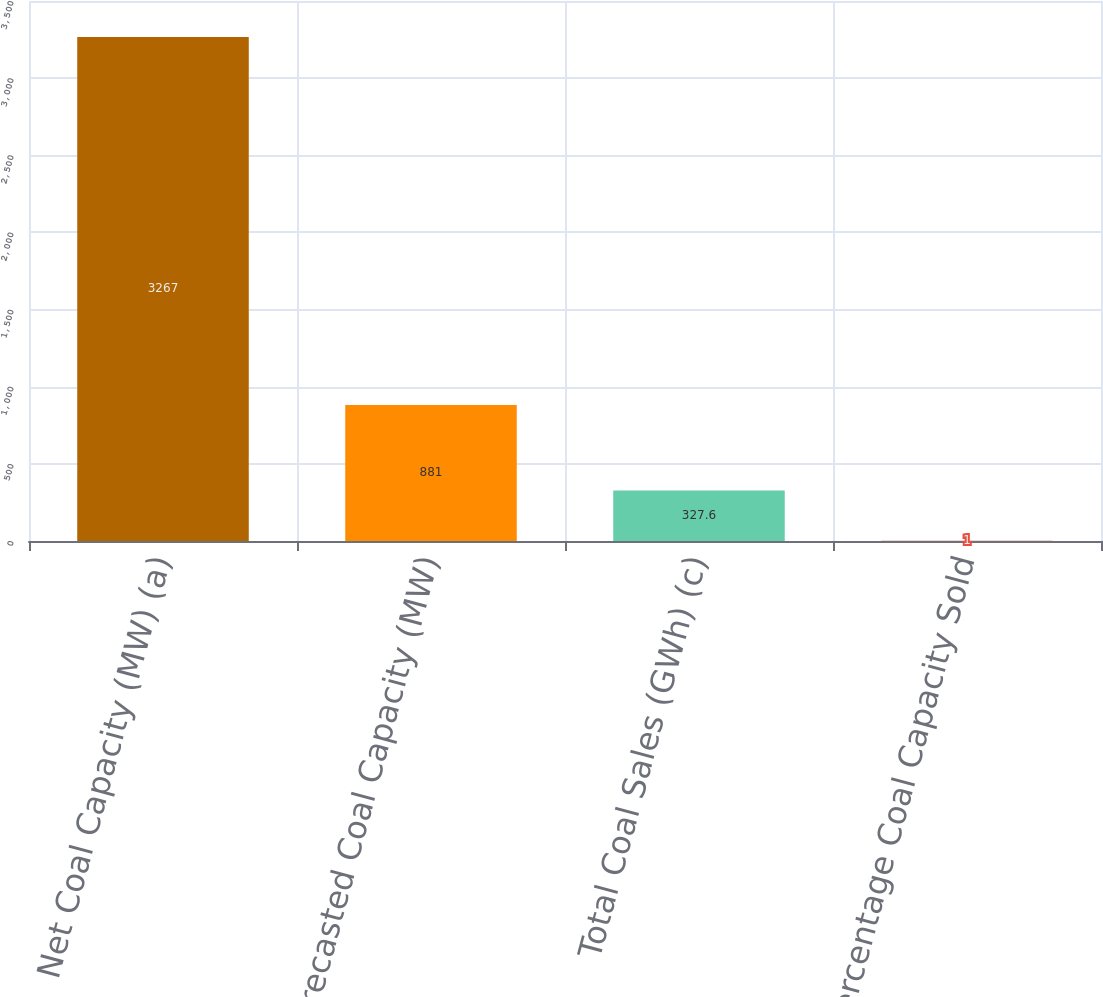Convert chart to OTSL. <chart><loc_0><loc_0><loc_500><loc_500><bar_chart><fcel>Net Coal Capacity (MW) (a)<fcel>Forecasted Coal Capacity (MW)<fcel>Total Coal Sales (GWh) (c)<fcel>Percentage Coal Capacity Sold<nl><fcel>3267<fcel>881<fcel>327.6<fcel>1<nl></chart> 